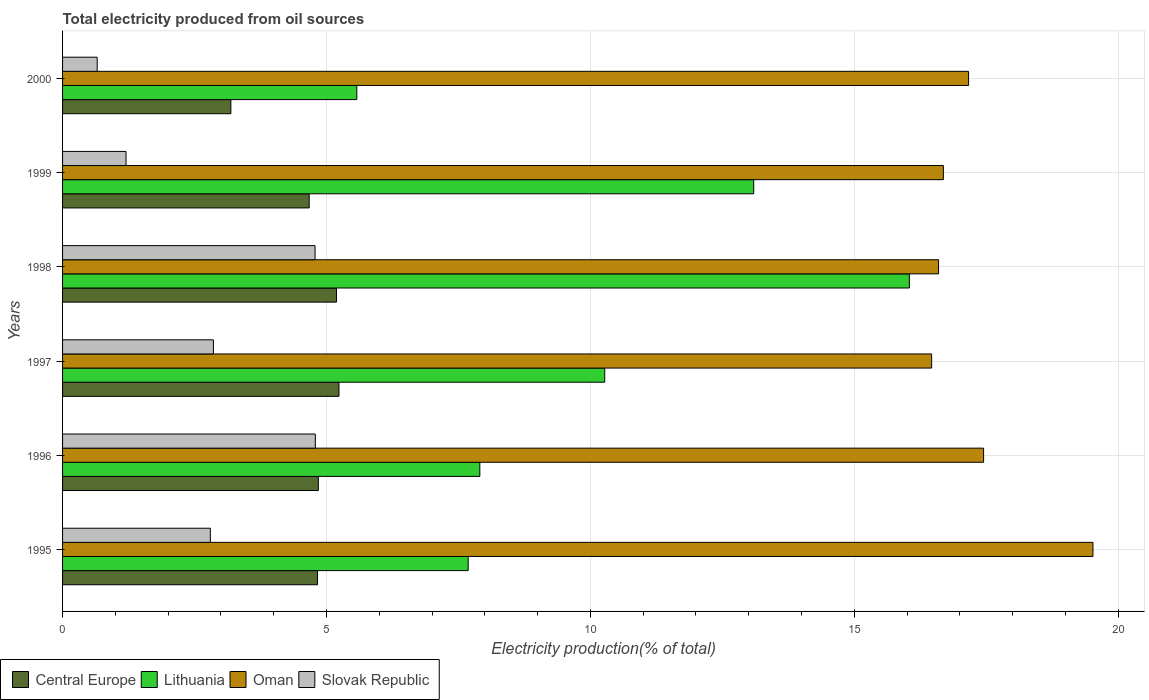How many different coloured bars are there?
Ensure brevity in your answer.  4. How many groups of bars are there?
Your answer should be very brief. 6. Are the number of bars on each tick of the Y-axis equal?
Provide a succinct answer. Yes. How many bars are there on the 5th tick from the top?
Provide a short and direct response. 4. What is the total electricity produced in Lithuania in 1995?
Give a very brief answer. 7.68. Across all years, what is the maximum total electricity produced in Lithuania?
Make the answer very short. 16.04. Across all years, what is the minimum total electricity produced in Lithuania?
Offer a very short reply. 5.58. In which year was the total electricity produced in Central Europe maximum?
Your answer should be very brief. 1997. What is the total total electricity produced in Oman in the graph?
Your answer should be compact. 103.89. What is the difference between the total electricity produced in Lithuania in 1995 and that in 2000?
Provide a short and direct response. 2.11. What is the difference between the total electricity produced in Oman in 2000 and the total electricity produced in Central Europe in 1998?
Offer a terse response. 11.98. What is the average total electricity produced in Lithuania per year?
Keep it short and to the point. 10.1. In the year 1998, what is the difference between the total electricity produced in Central Europe and total electricity produced in Oman?
Your answer should be compact. -11.41. What is the ratio of the total electricity produced in Central Europe in 1995 to that in 1998?
Ensure brevity in your answer.  0.93. Is the difference between the total electricity produced in Central Europe in 1996 and 1997 greater than the difference between the total electricity produced in Oman in 1996 and 1997?
Offer a terse response. No. What is the difference between the highest and the second highest total electricity produced in Oman?
Provide a short and direct response. 2.07. What is the difference between the highest and the lowest total electricity produced in Slovak Republic?
Offer a very short reply. 4.13. In how many years, is the total electricity produced in Lithuania greater than the average total electricity produced in Lithuania taken over all years?
Ensure brevity in your answer.  3. Is it the case that in every year, the sum of the total electricity produced in Oman and total electricity produced in Slovak Republic is greater than the sum of total electricity produced in Central Europe and total electricity produced in Lithuania?
Give a very brief answer. No. What does the 2nd bar from the top in 1999 represents?
Give a very brief answer. Oman. What does the 1st bar from the bottom in 2000 represents?
Keep it short and to the point. Central Europe. Is it the case that in every year, the sum of the total electricity produced in Oman and total electricity produced in Slovak Republic is greater than the total electricity produced in Central Europe?
Give a very brief answer. Yes. Are all the bars in the graph horizontal?
Offer a terse response. Yes. Are the values on the major ticks of X-axis written in scientific E-notation?
Keep it short and to the point. No. How many legend labels are there?
Ensure brevity in your answer.  4. What is the title of the graph?
Provide a succinct answer. Total electricity produced from oil sources. What is the label or title of the X-axis?
Keep it short and to the point. Electricity production(% of total). What is the Electricity production(% of total) of Central Europe in 1995?
Your response must be concise. 4.83. What is the Electricity production(% of total) in Lithuania in 1995?
Provide a succinct answer. 7.68. What is the Electricity production(% of total) in Oman in 1995?
Offer a terse response. 19.52. What is the Electricity production(% of total) of Slovak Republic in 1995?
Your response must be concise. 2.8. What is the Electricity production(% of total) of Central Europe in 1996?
Provide a succinct answer. 4.85. What is the Electricity production(% of total) of Lithuania in 1996?
Make the answer very short. 7.91. What is the Electricity production(% of total) of Oman in 1996?
Make the answer very short. 17.45. What is the Electricity production(% of total) in Slovak Republic in 1996?
Offer a very short reply. 4.79. What is the Electricity production(% of total) in Central Europe in 1997?
Offer a terse response. 5.24. What is the Electricity production(% of total) of Lithuania in 1997?
Offer a very short reply. 10.27. What is the Electricity production(% of total) in Oman in 1997?
Your answer should be compact. 16.47. What is the Electricity production(% of total) of Slovak Republic in 1997?
Make the answer very short. 2.86. What is the Electricity production(% of total) in Central Europe in 1998?
Ensure brevity in your answer.  5.19. What is the Electricity production(% of total) of Lithuania in 1998?
Make the answer very short. 16.04. What is the Electricity production(% of total) of Oman in 1998?
Ensure brevity in your answer.  16.6. What is the Electricity production(% of total) in Slovak Republic in 1998?
Offer a terse response. 4.78. What is the Electricity production(% of total) in Central Europe in 1999?
Give a very brief answer. 4.67. What is the Electricity production(% of total) in Lithuania in 1999?
Ensure brevity in your answer.  13.09. What is the Electricity production(% of total) of Oman in 1999?
Provide a succinct answer. 16.69. What is the Electricity production(% of total) of Slovak Republic in 1999?
Your response must be concise. 1.2. What is the Electricity production(% of total) of Central Europe in 2000?
Give a very brief answer. 3.19. What is the Electricity production(% of total) in Lithuania in 2000?
Offer a terse response. 5.58. What is the Electricity production(% of total) in Oman in 2000?
Your response must be concise. 17.17. What is the Electricity production(% of total) in Slovak Republic in 2000?
Offer a terse response. 0.66. Across all years, what is the maximum Electricity production(% of total) in Central Europe?
Offer a terse response. 5.24. Across all years, what is the maximum Electricity production(% of total) of Lithuania?
Offer a terse response. 16.04. Across all years, what is the maximum Electricity production(% of total) of Oman?
Offer a terse response. 19.52. Across all years, what is the maximum Electricity production(% of total) of Slovak Republic?
Your answer should be compact. 4.79. Across all years, what is the minimum Electricity production(% of total) in Central Europe?
Your response must be concise. 3.19. Across all years, what is the minimum Electricity production(% of total) in Lithuania?
Your answer should be very brief. 5.58. Across all years, what is the minimum Electricity production(% of total) in Oman?
Keep it short and to the point. 16.47. Across all years, what is the minimum Electricity production(% of total) of Slovak Republic?
Your answer should be compact. 0.66. What is the total Electricity production(% of total) in Central Europe in the graph?
Give a very brief answer. 27.96. What is the total Electricity production(% of total) in Lithuania in the graph?
Your response must be concise. 60.58. What is the total Electricity production(% of total) of Oman in the graph?
Provide a succinct answer. 103.89. What is the total Electricity production(% of total) in Slovak Republic in the graph?
Your answer should be very brief. 17.09. What is the difference between the Electricity production(% of total) in Central Europe in 1995 and that in 1996?
Offer a terse response. -0.02. What is the difference between the Electricity production(% of total) in Lithuania in 1995 and that in 1996?
Your answer should be very brief. -0.22. What is the difference between the Electricity production(% of total) in Oman in 1995 and that in 1996?
Ensure brevity in your answer.  2.07. What is the difference between the Electricity production(% of total) of Slovak Republic in 1995 and that in 1996?
Ensure brevity in your answer.  -1.99. What is the difference between the Electricity production(% of total) of Central Europe in 1995 and that in 1997?
Provide a short and direct response. -0.41. What is the difference between the Electricity production(% of total) in Lithuania in 1995 and that in 1997?
Offer a very short reply. -2.59. What is the difference between the Electricity production(% of total) in Oman in 1995 and that in 1997?
Offer a very short reply. 3.06. What is the difference between the Electricity production(% of total) of Slovak Republic in 1995 and that in 1997?
Your answer should be compact. -0.06. What is the difference between the Electricity production(% of total) of Central Europe in 1995 and that in 1998?
Offer a very short reply. -0.36. What is the difference between the Electricity production(% of total) in Lithuania in 1995 and that in 1998?
Your answer should be very brief. -8.36. What is the difference between the Electricity production(% of total) of Oman in 1995 and that in 1998?
Offer a very short reply. 2.93. What is the difference between the Electricity production(% of total) in Slovak Republic in 1995 and that in 1998?
Your answer should be compact. -1.98. What is the difference between the Electricity production(% of total) of Central Europe in 1995 and that in 1999?
Make the answer very short. 0.16. What is the difference between the Electricity production(% of total) in Lithuania in 1995 and that in 1999?
Provide a short and direct response. -5.41. What is the difference between the Electricity production(% of total) of Oman in 1995 and that in 1999?
Your answer should be very brief. 2.83. What is the difference between the Electricity production(% of total) in Slovak Republic in 1995 and that in 1999?
Provide a short and direct response. 1.6. What is the difference between the Electricity production(% of total) of Central Europe in 1995 and that in 2000?
Provide a short and direct response. 1.64. What is the difference between the Electricity production(% of total) of Lithuania in 1995 and that in 2000?
Your answer should be compact. 2.11. What is the difference between the Electricity production(% of total) in Oman in 1995 and that in 2000?
Ensure brevity in your answer.  2.36. What is the difference between the Electricity production(% of total) in Slovak Republic in 1995 and that in 2000?
Ensure brevity in your answer.  2.14. What is the difference between the Electricity production(% of total) in Central Europe in 1996 and that in 1997?
Provide a succinct answer. -0.39. What is the difference between the Electricity production(% of total) in Lithuania in 1996 and that in 1997?
Make the answer very short. -2.37. What is the difference between the Electricity production(% of total) in Oman in 1996 and that in 1997?
Ensure brevity in your answer.  0.98. What is the difference between the Electricity production(% of total) of Slovak Republic in 1996 and that in 1997?
Offer a terse response. 1.93. What is the difference between the Electricity production(% of total) in Central Europe in 1996 and that in 1998?
Offer a very short reply. -0.34. What is the difference between the Electricity production(% of total) of Lithuania in 1996 and that in 1998?
Your answer should be compact. -8.14. What is the difference between the Electricity production(% of total) of Oman in 1996 and that in 1998?
Keep it short and to the point. 0.85. What is the difference between the Electricity production(% of total) of Slovak Republic in 1996 and that in 1998?
Your answer should be compact. 0.01. What is the difference between the Electricity production(% of total) in Central Europe in 1996 and that in 1999?
Your answer should be very brief. 0.17. What is the difference between the Electricity production(% of total) of Lithuania in 1996 and that in 1999?
Provide a succinct answer. -5.19. What is the difference between the Electricity production(% of total) in Oman in 1996 and that in 1999?
Your answer should be very brief. 0.76. What is the difference between the Electricity production(% of total) in Slovak Republic in 1996 and that in 1999?
Provide a short and direct response. 3.59. What is the difference between the Electricity production(% of total) of Central Europe in 1996 and that in 2000?
Provide a succinct answer. 1.66. What is the difference between the Electricity production(% of total) in Lithuania in 1996 and that in 2000?
Make the answer very short. 2.33. What is the difference between the Electricity production(% of total) in Oman in 1996 and that in 2000?
Your answer should be compact. 0.28. What is the difference between the Electricity production(% of total) of Slovak Republic in 1996 and that in 2000?
Give a very brief answer. 4.13. What is the difference between the Electricity production(% of total) in Central Europe in 1997 and that in 1998?
Give a very brief answer. 0.05. What is the difference between the Electricity production(% of total) in Lithuania in 1997 and that in 1998?
Offer a terse response. -5.77. What is the difference between the Electricity production(% of total) in Oman in 1997 and that in 1998?
Your answer should be compact. -0.13. What is the difference between the Electricity production(% of total) in Slovak Republic in 1997 and that in 1998?
Your answer should be very brief. -1.93. What is the difference between the Electricity production(% of total) in Central Europe in 1997 and that in 1999?
Your answer should be compact. 0.56. What is the difference between the Electricity production(% of total) of Lithuania in 1997 and that in 1999?
Your response must be concise. -2.82. What is the difference between the Electricity production(% of total) in Oman in 1997 and that in 1999?
Your answer should be very brief. -0.22. What is the difference between the Electricity production(% of total) of Slovak Republic in 1997 and that in 1999?
Your response must be concise. 1.66. What is the difference between the Electricity production(% of total) in Central Europe in 1997 and that in 2000?
Your answer should be compact. 2.05. What is the difference between the Electricity production(% of total) in Lithuania in 1997 and that in 2000?
Your answer should be compact. 4.7. What is the difference between the Electricity production(% of total) in Oman in 1997 and that in 2000?
Your answer should be very brief. -0.7. What is the difference between the Electricity production(% of total) of Slovak Republic in 1997 and that in 2000?
Provide a short and direct response. 2.2. What is the difference between the Electricity production(% of total) in Central Europe in 1998 and that in 1999?
Make the answer very short. 0.52. What is the difference between the Electricity production(% of total) of Lithuania in 1998 and that in 1999?
Provide a short and direct response. 2.95. What is the difference between the Electricity production(% of total) of Oman in 1998 and that in 1999?
Offer a very short reply. -0.09. What is the difference between the Electricity production(% of total) of Slovak Republic in 1998 and that in 1999?
Give a very brief answer. 3.58. What is the difference between the Electricity production(% of total) of Central Europe in 1998 and that in 2000?
Your answer should be compact. 2. What is the difference between the Electricity production(% of total) in Lithuania in 1998 and that in 2000?
Make the answer very short. 10.47. What is the difference between the Electricity production(% of total) of Oman in 1998 and that in 2000?
Your answer should be compact. -0.57. What is the difference between the Electricity production(% of total) of Slovak Republic in 1998 and that in 2000?
Your answer should be very brief. 4.13. What is the difference between the Electricity production(% of total) in Central Europe in 1999 and that in 2000?
Offer a terse response. 1.48. What is the difference between the Electricity production(% of total) of Lithuania in 1999 and that in 2000?
Keep it short and to the point. 7.52. What is the difference between the Electricity production(% of total) of Oman in 1999 and that in 2000?
Offer a terse response. -0.48. What is the difference between the Electricity production(% of total) in Slovak Republic in 1999 and that in 2000?
Make the answer very short. 0.55. What is the difference between the Electricity production(% of total) in Central Europe in 1995 and the Electricity production(% of total) in Lithuania in 1996?
Your response must be concise. -3.08. What is the difference between the Electricity production(% of total) in Central Europe in 1995 and the Electricity production(% of total) in Oman in 1996?
Your answer should be compact. -12.62. What is the difference between the Electricity production(% of total) of Central Europe in 1995 and the Electricity production(% of total) of Slovak Republic in 1996?
Offer a very short reply. 0.04. What is the difference between the Electricity production(% of total) in Lithuania in 1995 and the Electricity production(% of total) in Oman in 1996?
Your response must be concise. -9.77. What is the difference between the Electricity production(% of total) in Lithuania in 1995 and the Electricity production(% of total) in Slovak Republic in 1996?
Your answer should be compact. 2.9. What is the difference between the Electricity production(% of total) of Oman in 1995 and the Electricity production(% of total) of Slovak Republic in 1996?
Offer a very short reply. 14.73. What is the difference between the Electricity production(% of total) of Central Europe in 1995 and the Electricity production(% of total) of Lithuania in 1997?
Give a very brief answer. -5.44. What is the difference between the Electricity production(% of total) of Central Europe in 1995 and the Electricity production(% of total) of Oman in 1997?
Make the answer very short. -11.64. What is the difference between the Electricity production(% of total) in Central Europe in 1995 and the Electricity production(% of total) in Slovak Republic in 1997?
Your answer should be very brief. 1.97. What is the difference between the Electricity production(% of total) of Lithuania in 1995 and the Electricity production(% of total) of Oman in 1997?
Provide a succinct answer. -8.78. What is the difference between the Electricity production(% of total) in Lithuania in 1995 and the Electricity production(% of total) in Slovak Republic in 1997?
Keep it short and to the point. 4.83. What is the difference between the Electricity production(% of total) of Oman in 1995 and the Electricity production(% of total) of Slovak Republic in 1997?
Your answer should be compact. 16.67. What is the difference between the Electricity production(% of total) of Central Europe in 1995 and the Electricity production(% of total) of Lithuania in 1998?
Provide a short and direct response. -11.21. What is the difference between the Electricity production(% of total) in Central Europe in 1995 and the Electricity production(% of total) in Oman in 1998?
Your response must be concise. -11.77. What is the difference between the Electricity production(% of total) of Central Europe in 1995 and the Electricity production(% of total) of Slovak Republic in 1998?
Keep it short and to the point. 0.05. What is the difference between the Electricity production(% of total) of Lithuania in 1995 and the Electricity production(% of total) of Oman in 1998?
Ensure brevity in your answer.  -8.91. What is the difference between the Electricity production(% of total) of Lithuania in 1995 and the Electricity production(% of total) of Slovak Republic in 1998?
Offer a terse response. 2.9. What is the difference between the Electricity production(% of total) of Oman in 1995 and the Electricity production(% of total) of Slovak Republic in 1998?
Make the answer very short. 14.74. What is the difference between the Electricity production(% of total) in Central Europe in 1995 and the Electricity production(% of total) in Lithuania in 1999?
Ensure brevity in your answer.  -8.26. What is the difference between the Electricity production(% of total) of Central Europe in 1995 and the Electricity production(% of total) of Oman in 1999?
Your answer should be compact. -11.86. What is the difference between the Electricity production(% of total) in Central Europe in 1995 and the Electricity production(% of total) in Slovak Republic in 1999?
Give a very brief answer. 3.63. What is the difference between the Electricity production(% of total) of Lithuania in 1995 and the Electricity production(% of total) of Oman in 1999?
Ensure brevity in your answer.  -9. What is the difference between the Electricity production(% of total) of Lithuania in 1995 and the Electricity production(% of total) of Slovak Republic in 1999?
Give a very brief answer. 6.48. What is the difference between the Electricity production(% of total) of Oman in 1995 and the Electricity production(% of total) of Slovak Republic in 1999?
Make the answer very short. 18.32. What is the difference between the Electricity production(% of total) of Central Europe in 1995 and the Electricity production(% of total) of Lithuania in 2000?
Provide a succinct answer. -0.74. What is the difference between the Electricity production(% of total) in Central Europe in 1995 and the Electricity production(% of total) in Oman in 2000?
Offer a very short reply. -12.34. What is the difference between the Electricity production(% of total) of Central Europe in 1995 and the Electricity production(% of total) of Slovak Republic in 2000?
Offer a very short reply. 4.17. What is the difference between the Electricity production(% of total) of Lithuania in 1995 and the Electricity production(% of total) of Oman in 2000?
Keep it short and to the point. -9.48. What is the difference between the Electricity production(% of total) of Lithuania in 1995 and the Electricity production(% of total) of Slovak Republic in 2000?
Give a very brief answer. 7.03. What is the difference between the Electricity production(% of total) in Oman in 1995 and the Electricity production(% of total) in Slovak Republic in 2000?
Provide a short and direct response. 18.87. What is the difference between the Electricity production(% of total) in Central Europe in 1996 and the Electricity production(% of total) in Lithuania in 1997?
Keep it short and to the point. -5.43. What is the difference between the Electricity production(% of total) in Central Europe in 1996 and the Electricity production(% of total) in Oman in 1997?
Your answer should be compact. -11.62. What is the difference between the Electricity production(% of total) of Central Europe in 1996 and the Electricity production(% of total) of Slovak Republic in 1997?
Your answer should be very brief. 1.99. What is the difference between the Electricity production(% of total) of Lithuania in 1996 and the Electricity production(% of total) of Oman in 1997?
Offer a very short reply. -8.56. What is the difference between the Electricity production(% of total) of Lithuania in 1996 and the Electricity production(% of total) of Slovak Republic in 1997?
Offer a terse response. 5.05. What is the difference between the Electricity production(% of total) in Oman in 1996 and the Electricity production(% of total) in Slovak Republic in 1997?
Offer a terse response. 14.59. What is the difference between the Electricity production(% of total) in Central Europe in 1996 and the Electricity production(% of total) in Lithuania in 1998?
Provide a succinct answer. -11.2. What is the difference between the Electricity production(% of total) of Central Europe in 1996 and the Electricity production(% of total) of Oman in 1998?
Offer a very short reply. -11.75. What is the difference between the Electricity production(% of total) in Central Europe in 1996 and the Electricity production(% of total) in Slovak Republic in 1998?
Give a very brief answer. 0.06. What is the difference between the Electricity production(% of total) of Lithuania in 1996 and the Electricity production(% of total) of Oman in 1998?
Offer a very short reply. -8.69. What is the difference between the Electricity production(% of total) in Lithuania in 1996 and the Electricity production(% of total) in Slovak Republic in 1998?
Make the answer very short. 3.12. What is the difference between the Electricity production(% of total) in Oman in 1996 and the Electricity production(% of total) in Slovak Republic in 1998?
Your answer should be compact. 12.67. What is the difference between the Electricity production(% of total) of Central Europe in 1996 and the Electricity production(% of total) of Lithuania in 1999?
Provide a succinct answer. -8.25. What is the difference between the Electricity production(% of total) in Central Europe in 1996 and the Electricity production(% of total) in Oman in 1999?
Offer a terse response. -11.84. What is the difference between the Electricity production(% of total) of Central Europe in 1996 and the Electricity production(% of total) of Slovak Republic in 1999?
Keep it short and to the point. 3.64. What is the difference between the Electricity production(% of total) of Lithuania in 1996 and the Electricity production(% of total) of Oman in 1999?
Provide a succinct answer. -8.78. What is the difference between the Electricity production(% of total) of Lithuania in 1996 and the Electricity production(% of total) of Slovak Republic in 1999?
Ensure brevity in your answer.  6.7. What is the difference between the Electricity production(% of total) of Oman in 1996 and the Electricity production(% of total) of Slovak Republic in 1999?
Your answer should be very brief. 16.25. What is the difference between the Electricity production(% of total) of Central Europe in 1996 and the Electricity production(% of total) of Lithuania in 2000?
Offer a terse response. -0.73. What is the difference between the Electricity production(% of total) of Central Europe in 1996 and the Electricity production(% of total) of Oman in 2000?
Provide a succinct answer. -12.32. What is the difference between the Electricity production(% of total) in Central Europe in 1996 and the Electricity production(% of total) in Slovak Republic in 2000?
Provide a short and direct response. 4.19. What is the difference between the Electricity production(% of total) in Lithuania in 1996 and the Electricity production(% of total) in Oman in 2000?
Provide a succinct answer. -9.26. What is the difference between the Electricity production(% of total) in Lithuania in 1996 and the Electricity production(% of total) in Slovak Republic in 2000?
Give a very brief answer. 7.25. What is the difference between the Electricity production(% of total) in Oman in 1996 and the Electricity production(% of total) in Slovak Republic in 2000?
Give a very brief answer. 16.79. What is the difference between the Electricity production(% of total) of Central Europe in 1997 and the Electricity production(% of total) of Lithuania in 1998?
Your response must be concise. -10.81. What is the difference between the Electricity production(% of total) in Central Europe in 1997 and the Electricity production(% of total) in Oman in 1998?
Offer a very short reply. -11.36. What is the difference between the Electricity production(% of total) of Central Europe in 1997 and the Electricity production(% of total) of Slovak Republic in 1998?
Keep it short and to the point. 0.45. What is the difference between the Electricity production(% of total) of Lithuania in 1997 and the Electricity production(% of total) of Oman in 1998?
Provide a succinct answer. -6.33. What is the difference between the Electricity production(% of total) of Lithuania in 1997 and the Electricity production(% of total) of Slovak Republic in 1998?
Ensure brevity in your answer.  5.49. What is the difference between the Electricity production(% of total) of Oman in 1997 and the Electricity production(% of total) of Slovak Republic in 1998?
Your answer should be very brief. 11.68. What is the difference between the Electricity production(% of total) of Central Europe in 1997 and the Electricity production(% of total) of Lithuania in 1999?
Give a very brief answer. -7.86. What is the difference between the Electricity production(% of total) in Central Europe in 1997 and the Electricity production(% of total) in Oman in 1999?
Your answer should be compact. -11.45. What is the difference between the Electricity production(% of total) of Central Europe in 1997 and the Electricity production(% of total) of Slovak Republic in 1999?
Your answer should be very brief. 4.03. What is the difference between the Electricity production(% of total) in Lithuania in 1997 and the Electricity production(% of total) in Oman in 1999?
Your answer should be compact. -6.42. What is the difference between the Electricity production(% of total) of Lithuania in 1997 and the Electricity production(% of total) of Slovak Republic in 1999?
Your response must be concise. 9.07. What is the difference between the Electricity production(% of total) of Oman in 1997 and the Electricity production(% of total) of Slovak Republic in 1999?
Ensure brevity in your answer.  15.26. What is the difference between the Electricity production(% of total) of Central Europe in 1997 and the Electricity production(% of total) of Lithuania in 2000?
Your answer should be compact. -0.34. What is the difference between the Electricity production(% of total) of Central Europe in 1997 and the Electricity production(% of total) of Oman in 2000?
Ensure brevity in your answer.  -11.93. What is the difference between the Electricity production(% of total) of Central Europe in 1997 and the Electricity production(% of total) of Slovak Republic in 2000?
Your answer should be compact. 4.58. What is the difference between the Electricity production(% of total) of Lithuania in 1997 and the Electricity production(% of total) of Oman in 2000?
Ensure brevity in your answer.  -6.89. What is the difference between the Electricity production(% of total) in Lithuania in 1997 and the Electricity production(% of total) in Slovak Republic in 2000?
Ensure brevity in your answer.  9.62. What is the difference between the Electricity production(% of total) of Oman in 1997 and the Electricity production(% of total) of Slovak Republic in 2000?
Offer a terse response. 15.81. What is the difference between the Electricity production(% of total) of Central Europe in 1998 and the Electricity production(% of total) of Lithuania in 1999?
Give a very brief answer. -7.91. What is the difference between the Electricity production(% of total) of Central Europe in 1998 and the Electricity production(% of total) of Oman in 1999?
Make the answer very short. -11.5. What is the difference between the Electricity production(% of total) of Central Europe in 1998 and the Electricity production(% of total) of Slovak Republic in 1999?
Make the answer very short. 3.99. What is the difference between the Electricity production(% of total) of Lithuania in 1998 and the Electricity production(% of total) of Oman in 1999?
Your response must be concise. -0.64. What is the difference between the Electricity production(% of total) in Lithuania in 1998 and the Electricity production(% of total) in Slovak Republic in 1999?
Offer a terse response. 14.84. What is the difference between the Electricity production(% of total) in Oman in 1998 and the Electricity production(% of total) in Slovak Republic in 1999?
Make the answer very short. 15.39. What is the difference between the Electricity production(% of total) in Central Europe in 1998 and the Electricity production(% of total) in Lithuania in 2000?
Ensure brevity in your answer.  -0.39. What is the difference between the Electricity production(% of total) of Central Europe in 1998 and the Electricity production(% of total) of Oman in 2000?
Provide a succinct answer. -11.98. What is the difference between the Electricity production(% of total) in Central Europe in 1998 and the Electricity production(% of total) in Slovak Republic in 2000?
Your response must be concise. 4.53. What is the difference between the Electricity production(% of total) of Lithuania in 1998 and the Electricity production(% of total) of Oman in 2000?
Provide a short and direct response. -1.12. What is the difference between the Electricity production(% of total) of Lithuania in 1998 and the Electricity production(% of total) of Slovak Republic in 2000?
Give a very brief answer. 15.39. What is the difference between the Electricity production(% of total) of Oman in 1998 and the Electricity production(% of total) of Slovak Republic in 2000?
Your response must be concise. 15.94. What is the difference between the Electricity production(% of total) in Central Europe in 1999 and the Electricity production(% of total) in Lithuania in 2000?
Give a very brief answer. -0.9. What is the difference between the Electricity production(% of total) of Central Europe in 1999 and the Electricity production(% of total) of Oman in 2000?
Give a very brief answer. -12.49. What is the difference between the Electricity production(% of total) in Central Europe in 1999 and the Electricity production(% of total) in Slovak Republic in 2000?
Offer a terse response. 4.02. What is the difference between the Electricity production(% of total) of Lithuania in 1999 and the Electricity production(% of total) of Oman in 2000?
Provide a short and direct response. -4.07. What is the difference between the Electricity production(% of total) in Lithuania in 1999 and the Electricity production(% of total) in Slovak Republic in 2000?
Offer a terse response. 12.44. What is the difference between the Electricity production(% of total) of Oman in 1999 and the Electricity production(% of total) of Slovak Republic in 2000?
Provide a short and direct response. 16.03. What is the average Electricity production(% of total) of Central Europe per year?
Your response must be concise. 4.66. What is the average Electricity production(% of total) of Lithuania per year?
Provide a short and direct response. 10.1. What is the average Electricity production(% of total) of Oman per year?
Offer a very short reply. 17.32. What is the average Electricity production(% of total) in Slovak Republic per year?
Your answer should be very brief. 2.85. In the year 1995, what is the difference between the Electricity production(% of total) of Central Europe and Electricity production(% of total) of Lithuania?
Your answer should be compact. -2.85. In the year 1995, what is the difference between the Electricity production(% of total) in Central Europe and Electricity production(% of total) in Oman?
Offer a very short reply. -14.69. In the year 1995, what is the difference between the Electricity production(% of total) of Central Europe and Electricity production(% of total) of Slovak Republic?
Keep it short and to the point. 2.03. In the year 1995, what is the difference between the Electricity production(% of total) in Lithuania and Electricity production(% of total) in Oman?
Your answer should be very brief. -11.84. In the year 1995, what is the difference between the Electricity production(% of total) in Lithuania and Electricity production(% of total) in Slovak Republic?
Provide a short and direct response. 4.88. In the year 1995, what is the difference between the Electricity production(% of total) in Oman and Electricity production(% of total) in Slovak Republic?
Provide a succinct answer. 16.72. In the year 1996, what is the difference between the Electricity production(% of total) of Central Europe and Electricity production(% of total) of Lithuania?
Offer a very short reply. -3.06. In the year 1996, what is the difference between the Electricity production(% of total) of Central Europe and Electricity production(% of total) of Oman?
Offer a terse response. -12.6. In the year 1996, what is the difference between the Electricity production(% of total) in Central Europe and Electricity production(% of total) in Slovak Republic?
Offer a very short reply. 0.06. In the year 1996, what is the difference between the Electricity production(% of total) in Lithuania and Electricity production(% of total) in Oman?
Your answer should be very brief. -9.54. In the year 1996, what is the difference between the Electricity production(% of total) of Lithuania and Electricity production(% of total) of Slovak Republic?
Your answer should be very brief. 3.12. In the year 1996, what is the difference between the Electricity production(% of total) of Oman and Electricity production(% of total) of Slovak Republic?
Keep it short and to the point. 12.66. In the year 1997, what is the difference between the Electricity production(% of total) of Central Europe and Electricity production(% of total) of Lithuania?
Provide a succinct answer. -5.04. In the year 1997, what is the difference between the Electricity production(% of total) in Central Europe and Electricity production(% of total) in Oman?
Offer a terse response. -11.23. In the year 1997, what is the difference between the Electricity production(% of total) of Central Europe and Electricity production(% of total) of Slovak Republic?
Ensure brevity in your answer.  2.38. In the year 1997, what is the difference between the Electricity production(% of total) in Lithuania and Electricity production(% of total) in Oman?
Provide a succinct answer. -6.19. In the year 1997, what is the difference between the Electricity production(% of total) of Lithuania and Electricity production(% of total) of Slovak Republic?
Provide a succinct answer. 7.41. In the year 1997, what is the difference between the Electricity production(% of total) of Oman and Electricity production(% of total) of Slovak Republic?
Keep it short and to the point. 13.61. In the year 1998, what is the difference between the Electricity production(% of total) in Central Europe and Electricity production(% of total) in Lithuania?
Your response must be concise. -10.85. In the year 1998, what is the difference between the Electricity production(% of total) in Central Europe and Electricity production(% of total) in Oman?
Give a very brief answer. -11.41. In the year 1998, what is the difference between the Electricity production(% of total) in Central Europe and Electricity production(% of total) in Slovak Republic?
Provide a short and direct response. 0.41. In the year 1998, what is the difference between the Electricity production(% of total) in Lithuania and Electricity production(% of total) in Oman?
Provide a short and direct response. -0.55. In the year 1998, what is the difference between the Electricity production(% of total) of Lithuania and Electricity production(% of total) of Slovak Republic?
Offer a very short reply. 11.26. In the year 1998, what is the difference between the Electricity production(% of total) in Oman and Electricity production(% of total) in Slovak Republic?
Give a very brief answer. 11.81. In the year 1999, what is the difference between the Electricity production(% of total) of Central Europe and Electricity production(% of total) of Lithuania?
Your answer should be compact. -8.42. In the year 1999, what is the difference between the Electricity production(% of total) in Central Europe and Electricity production(% of total) in Oman?
Offer a terse response. -12.02. In the year 1999, what is the difference between the Electricity production(% of total) in Central Europe and Electricity production(% of total) in Slovak Republic?
Provide a succinct answer. 3.47. In the year 1999, what is the difference between the Electricity production(% of total) in Lithuania and Electricity production(% of total) in Oman?
Give a very brief answer. -3.59. In the year 1999, what is the difference between the Electricity production(% of total) in Lithuania and Electricity production(% of total) in Slovak Republic?
Your answer should be very brief. 11.89. In the year 1999, what is the difference between the Electricity production(% of total) of Oman and Electricity production(% of total) of Slovak Republic?
Your response must be concise. 15.49. In the year 2000, what is the difference between the Electricity production(% of total) of Central Europe and Electricity production(% of total) of Lithuania?
Keep it short and to the point. -2.39. In the year 2000, what is the difference between the Electricity production(% of total) of Central Europe and Electricity production(% of total) of Oman?
Your answer should be very brief. -13.98. In the year 2000, what is the difference between the Electricity production(% of total) of Central Europe and Electricity production(% of total) of Slovak Republic?
Offer a very short reply. 2.53. In the year 2000, what is the difference between the Electricity production(% of total) in Lithuania and Electricity production(% of total) in Oman?
Your answer should be very brief. -11.59. In the year 2000, what is the difference between the Electricity production(% of total) in Lithuania and Electricity production(% of total) in Slovak Republic?
Give a very brief answer. 4.92. In the year 2000, what is the difference between the Electricity production(% of total) of Oman and Electricity production(% of total) of Slovak Republic?
Give a very brief answer. 16.51. What is the ratio of the Electricity production(% of total) in Lithuania in 1995 to that in 1996?
Offer a terse response. 0.97. What is the ratio of the Electricity production(% of total) of Oman in 1995 to that in 1996?
Your answer should be compact. 1.12. What is the ratio of the Electricity production(% of total) in Slovak Republic in 1995 to that in 1996?
Make the answer very short. 0.58. What is the ratio of the Electricity production(% of total) in Central Europe in 1995 to that in 1997?
Offer a terse response. 0.92. What is the ratio of the Electricity production(% of total) in Lithuania in 1995 to that in 1997?
Your answer should be compact. 0.75. What is the ratio of the Electricity production(% of total) in Oman in 1995 to that in 1997?
Offer a terse response. 1.19. What is the ratio of the Electricity production(% of total) of Slovak Republic in 1995 to that in 1997?
Provide a succinct answer. 0.98. What is the ratio of the Electricity production(% of total) in Central Europe in 1995 to that in 1998?
Your response must be concise. 0.93. What is the ratio of the Electricity production(% of total) of Lithuania in 1995 to that in 1998?
Ensure brevity in your answer.  0.48. What is the ratio of the Electricity production(% of total) of Oman in 1995 to that in 1998?
Keep it short and to the point. 1.18. What is the ratio of the Electricity production(% of total) in Slovak Republic in 1995 to that in 1998?
Give a very brief answer. 0.59. What is the ratio of the Electricity production(% of total) in Central Europe in 1995 to that in 1999?
Provide a succinct answer. 1.03. What is the ratio of the Electricity production(% of total) of Lithuania in 1995 to that in 1999?
Your answer should be very brief. 0.59. What is the ratio of the Electricity production(% of total) in Oman in 1995 to that in 1999?
Ensure brevity in your answer.  1.17. What is the ratio of the Electricity production(% of total) in Slovak Republic in 1995 to that in 1999?
Ensure brevity in your answer.  2.33. What is the ratio of the Electricity production(% of total) of Central Europe in 1995 to that in 2000?
Provide a succinct answer. 1.51. What is the ratio of the Electricity production(% of total) of Lithuania in 1995 to that in 2000?
Give a very brief answer. 1.38. What is the ratio of the Electricity production(% of total) in Oman in 1995 to that in 2000?
Keep it short and to the point. 1.14. What is the ratio of the Electricity production(% of total) of Slovak Republic in 1995 to that in 2000?
Your answer should be very brief. 4.27. What is the ratio of the Electricity production(% of total) of Central Europe in 1996 to that in 1997?
Your response must be concise. 0.93. What is the ratio of the Electricity production(% of total) in Lithuania in 1996 to that in 1997?
Offer a terse response. 0.77. What is the ratio of the Electricity production(% of total) of Oman in 1996 to that in 1997?
Offer a terse response. 1.06. What is the ratio of the Electricity production(% of total) of Slovak Republic in 1996 to that in 1997?
Ensure brevity in your answer.  1.68. What is the ratio of the Electricity production(% of total) in Central Europe in 1996 to that in 1998?
Offer a terse response. 0.93. What is the ratio of the Electricity production(% of total) in Lithuania in 1996 to that in 1998?
Make the answer very short. 0.49. What is the ratio of the Electricity production(% of total) of Oman in 1996 to that in 1998?
Keep it short and to the point. 1.05. What is the ratio of the Electricity production(% of total) of Slovak Republic in 1996 to that in 1998?
Ensure brevity in your answer.  1. What is the ratio of the Electricity production(% of total) in Central Europe in 1996 to that in 1999?
Ensure brevity in your answer.  1.04. What is the ratio of the Electricity production(% of total) of Lithuania in 1996 to that in 1999?
Make the answer very short. 0.6. What is the ratio of the Electricity production(% of total) of Oman in 1996 to that in 1999?
Offer a very short reply. 1.05. What is the ratio of the Electricity production(% of total) in Slovak Republic in 1996 to that in 1999?
Provide a short and direct response. 3.98. What is the ratio of the Electricity production(% of total) in Central Europe in 1996 to that in 2000?
Make the answer very short. 1.52. What is the ratio of the Electricity production(% of total) in Lithuania in 1996 to that in 2000?
Your answer should be very brief. 1.42. What is the ratio of the Electricity production(% of total) of Oman in 1996 to that in 2000?
Offer a terse response. 1.02. What is the ratio of the Electricity production(% of total) in Slovak Republic in 1996 to that in 2000?
Ensure brevity in your answer.  7.3. What is the ratio of the Electricity production(% of total) of Central Europe in 1997 to that in 1998?
Your answer should be very brief. 1.01. What is the ratio of the Electricity production(% of total) in Lithuania in 1997 to that in 1998?
Provide a short and direct response. 0.64. What is the ratio of the Electricity production(% of total) in Slovak Republic in 1997 to that in 1998?
Keep it short and to the point. 0.6. What is the ratio of the Electricity production(% of total) of Central Europe in 1997 to that in 1999?
Provide a succinct answer. 1.12. What is the ratio of the Electricity production(% of total) in Lithuania in 1997 to that in 1999?
Make the answer very short. 0.78. What is the ratio of the Electricity production(% of total) in Oman in 1997 to that in 1999?
Ensure brevity in your answer.  0.99. What is the ratio of the Electricity production(% of total) of Slovak Republic in 1997 to that in 1999?
Provide a succinct answer. 2.38. What is the ratio of the Electricity production(% of total) in Central Europe in 1997 to that in 2000?
Give a very brief answer. 1.64. What is the ratio of the Electricity production(% of total) of Lithuania in 1997 to that in 2000?
Ensure brevity in your answer.  1.84. What is the ratio of the Electricity production(% of total) in Oman in 1997 to that in 2000?
Offer a terse response. 0.96. What is the ratio of the Electricity production(% of total) of Slovak Republic in 1997 to that in 2000?
Make the answer very short. 4.36. What is the ratio of the Electricity production(% of total) in Central Europe in 1998 to that in 1999?
Offer a terse response. 1.11. What is the ratio of the Electricity production(% of total) of Lithuania in 1998 to that in 1999?
Your answer should be compact. 1.23. What is the ratio of the Electricity production(% of total) in Slovak Republic in 1998 to that in 1999?
Provide a succinct answer. 3.98. What is the ratio of the Electricity production(% of total) of Central Europe in 1998 to that in 2000?
Give a very brief answer. 1.63. What is the ratio of the Electricity production(% of total) in Lithuania in 1998 to that in 2000?
Keep it short and to the point. 2.88. What is the ratio of the Electricity production(% of total) of Oman in 1998 to that in 2000?
Give a very brief answer. 0.97. What is the ratio of the Electricity production(% of total) of Slovak Republic in 1998 to that in 2000?
Offer a terse response. 7.29. What is the ratio of the Electricity production(% of total) in Central Europe in 1999 to that in 2000?
Offer a terse response. 1.47. What is the ratio of the Electricity production(% of total) in Lithuania in 1999 to that in 2000?
Offer a terse response. 2.35. What is the ratio of the Electricity production(% of total) of Oman in 1999 to that in 2000?
Keep it short and to the point. 0.97. What is the ratio of the Electricity production(% of total) in Slovak Republic in 1999 to that in 2000?
Provide a short and direct response. 1.83. What is the difference between the highest and the second highest Electricity production(% of total) in Central Europe?
Your answer should be very brief. 0.05. What is the difference between the highest and the second highest Electricity production(% of total) in Lithuania?
Your response must be concise. 2.95. What is the difference between the highest and the second highest Electricity production(% of total) in Oman?
Your answer should be very brief. 2.07. What is the difference between the highest and the second highest Electricity production(% of total) in Slovak Republic?
Offer a very short reply. 0.01. What is the difference between the highest and the lowest Electricity production(% of total) in Central Europe?
Your answer should be very brief. 2.05. What is the difference between the highest and the lowest Electricity production(% of total) of Lithuania?
Give a very brief answer. 10.47. What is the difference between the highest and the lowest Electricity production(% of total) of Oman?
Keep it short and to the point. 3.06. What is the difference between the highest and the lowest Electricity production(% of total) of Slovak Republic?
Provide a short and direct response. 4.13. 